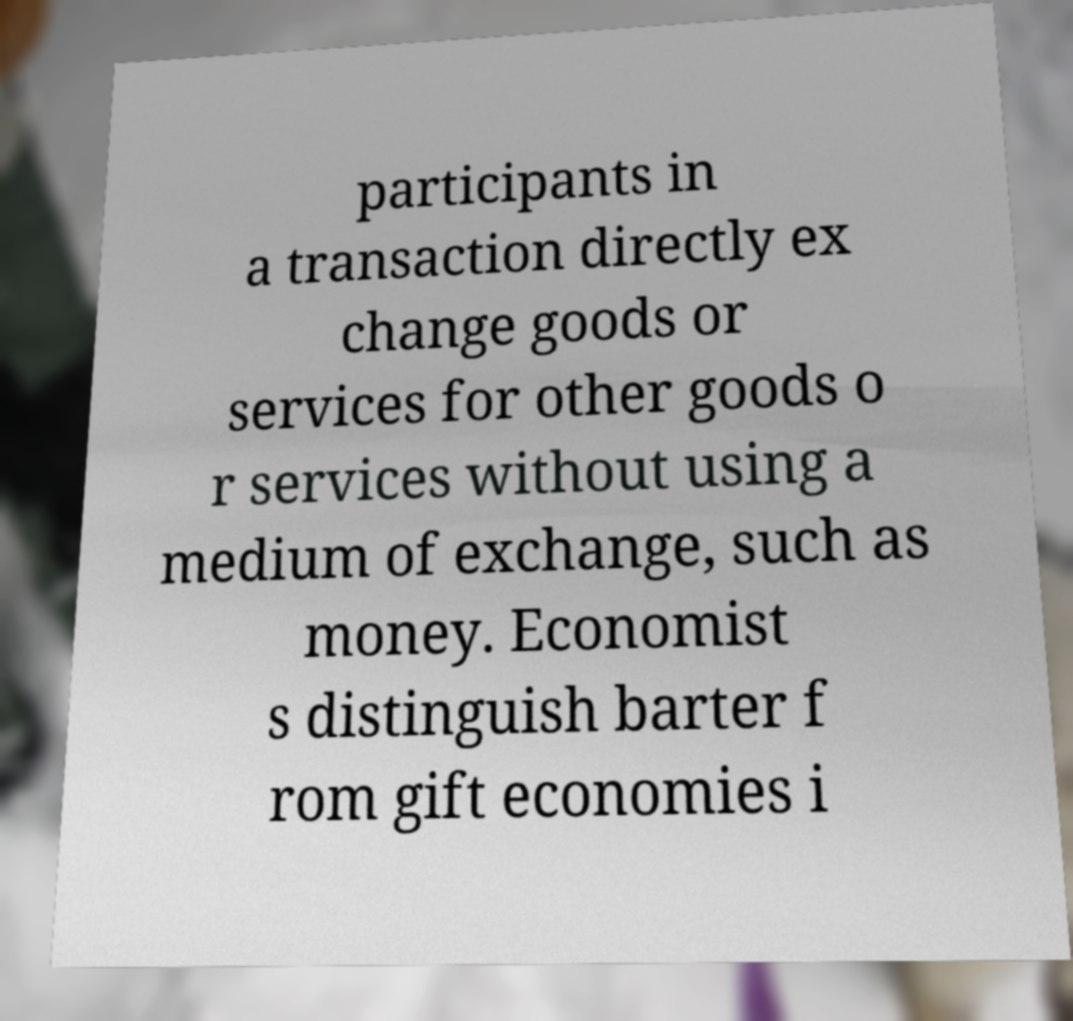I need the written content from this picture converted into text. Can you do that? participants in a transaction directly ex change goods or services for other goods o r services without using a medium of exchange, such as money. Economist s distinguish barter f rom gift economies i 